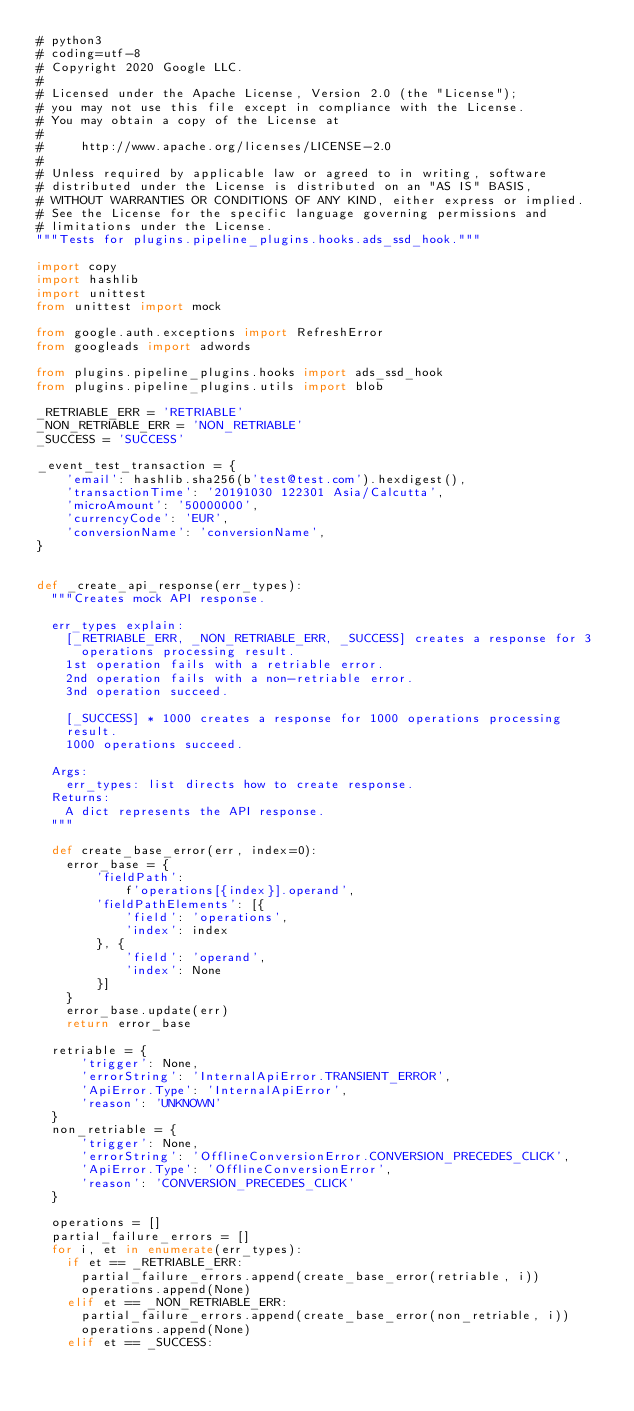Convert code to text. <code><loc_0><loc_0><loc_500><loc_500><_Python_># python3
# coding=utf-8
# Copyright 2020 Google LLC.
#
# Licensed under the Apache License, Version 2.0 (the "License");
# you may not use this file except in compliance with the License.
# You may obtain a copy of the License at
#
#     http://www.apache.org/licenses/LICENSE-2.0
#
# Unless required by applicable law or agreed to in writing, software
# distributed under the License is distributed on an "AS IS" BASIS,
# WITHOUT WARRANTIES OR CONDITIONS OF ANY KIND, either express or implied.
# See the License for the specific language governing permissions and
# limitations under the License.
"""Tests for plugins.pipeline_plugins.hooks.ads_ssd_hook."""

import copy
import hashlib
import unittest
from unittest import mock

from google.auth.exceptions import RefreshError
from googleads import adwords

from plugins.pipeline_plugins.hooks import ads_ssd_hook
from plugins.pipeline_plugins.utils import blob

_RETRIABLE_ERR = 'RETRIABLE'
_NON_RETRIABLE_ERR = 'NON_RETRIABLE'
_SUCCESS = 'SUCCESS'

_event_test_transaction = {
    'email': hashlib.sha256(b'test@test.com').hexdigest(),
    'transactionTime': '20191030 122301 Asia/Calcutta',
    'microAmount': '50000000',
    'currencyCode': 'EUR',
    'conversionName': 'conversionName',
}


def _create_api_response(err_types):
  """Creates mock API response.

  err_types explain:
    [_RETRIABLE_ERR, _NON_RETRIABLE_ERR, _SUCCESS] creates a response for 3
      operations processing result.
    1st operation fails with a retriable error.
    2nd operation fails with a non-retriable error.
    3nd operation succeed.

    [_SUCCESS] * 1000 creates a response for 1000 operations processing
    result.
    1000 operations succeed.

  Args:
    err_types: list directs how to create response.
  Returns:
    A dict represents the API response.
  """

  def create_base_error(err, index=0):
    error_base = {
        'fieldPath':
            f'operations[{index}].operand',
        'fieldPathElements': [{
            'field': 'operations',
            'index': index
        }, {
            'field': 'operand',
            'index': None
        }]
    }
    error_base.update(err)
    return error_base

  retriable = {
      'trigger': None,
      'errorString': 'InternalApiError.TRANSIENT_ERROR',
      'ApiError.Type': 'InternalApiError',
      'reason': 'UNKNOWN'
  }
  non_retriable = {
      'trigger': None,
      'errorString': 'OfflineConversionError.CONVERSION_PRECEDES_CLICK',
      'ApiError.Type': 'OfflineConversionError',
      'reason': 'CONVERSION_PRECEDES_CLICK'
  }

  operations = []
  partial_failure_errors = []
  for i, et in enumerate(err_types):
    if et == _RETRIABLE_ERR:
      partial_failure_errors.append(create_base_error(retriable, i))
      operations.append(None)
    elif et == _NON_RETRIABLE_ERR:
      partial_failure_errors.append(create_base_error(non_retriable, i))
      operations.append(None)
    elif et == _SUCCESS:</code> 